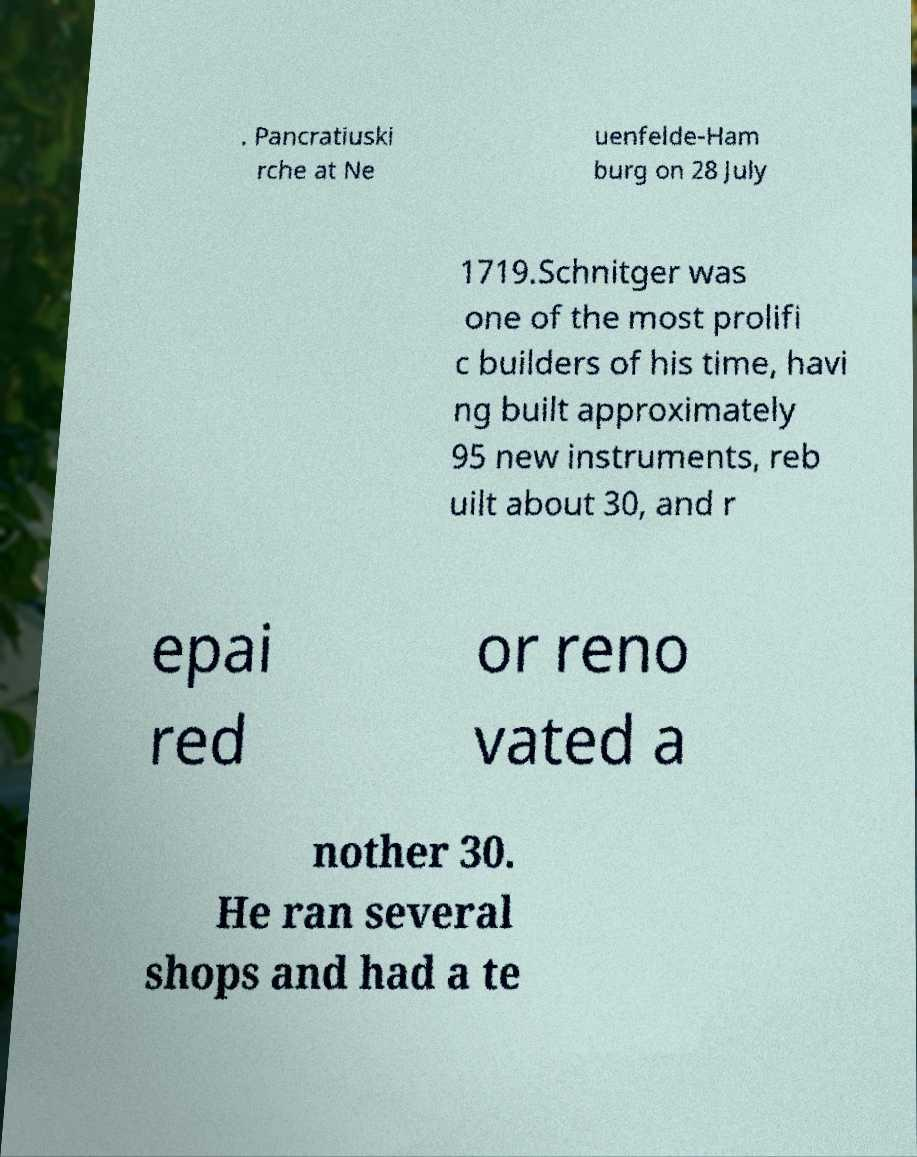What messages or text are displayed in this image? I need them in a readable, typed format. . Pancratiuski rche at Ne uenfelde-Ham burg on 28 July 1719.Schnitger was one of the most prolifi c builders of his time, havi ng built approximately 95 new instruments, reb uilt about 30, and r epai red or reno vated a nother 30. He ran several shops and had a te 